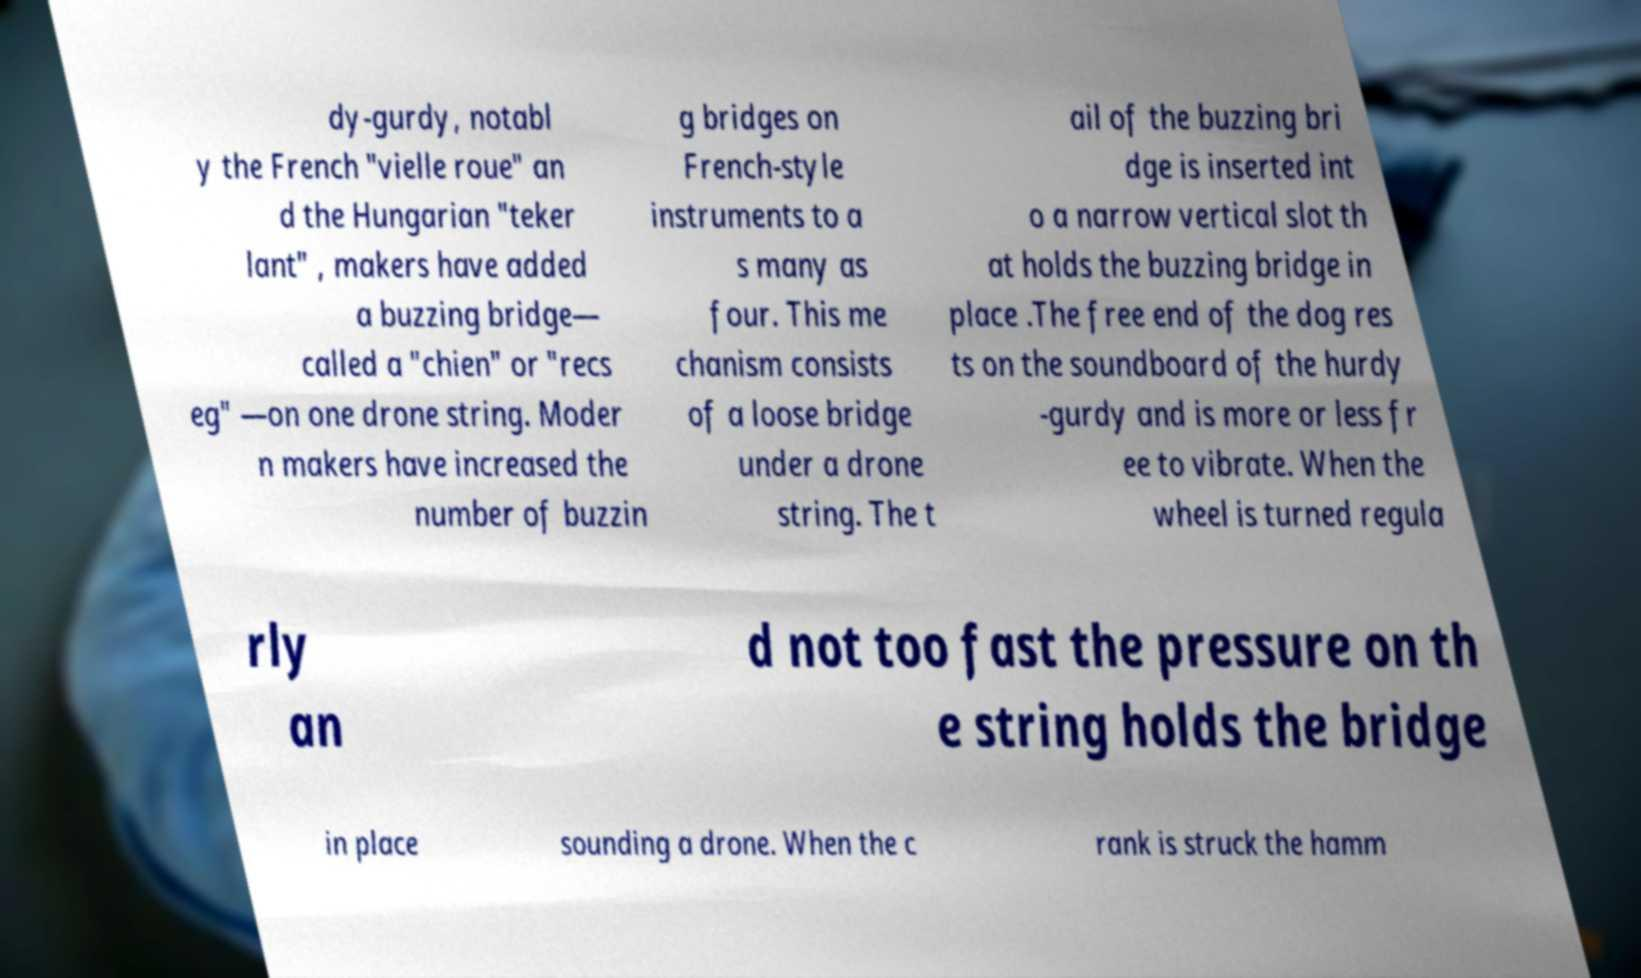I need the written content from this picture converted into text. Can you do that? dy-gurdy, notabl y the French "vielle roue" an d the Hungarian "teker lant" , makers have added a buzzing bridge— called a "chien" or "recs eg" —on one drone string. Moder n makers have increased the number of buzzin g bridges on French-style instruments to a s many as four. This me chanism consists of a loose bridge under a drone string. The t ail of the buzzing bri dge is inserted int o a narrow vertical slot th at holds the buzzing bridge in place .The free end of the dog res ts on the soundboard of the hurdy -gurdy and is more or less fr ee to vibrate. When the wheel is turned regula rly an d not too fast the pressure on th e string holds the bridge in place sounding a drone. When the c rank is struck the hamm 